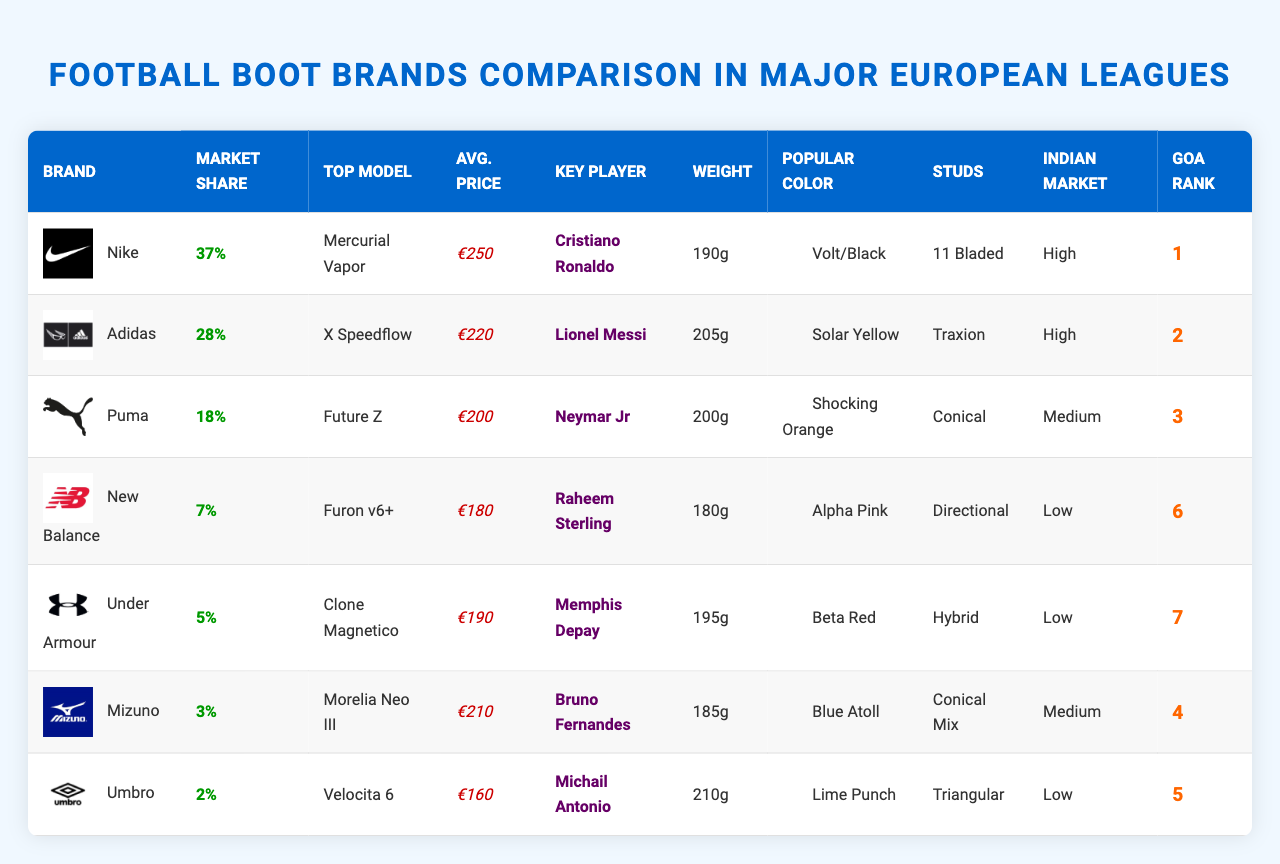What is the market share percentage of Nike boots? According to the table, Nike has a market share of 37%.
Answer: 37% Which boot brand has the highest selling price? The table shows that Nike boots have the highest average price at €250.
Answer: Nike What is the total market share of Adidas and Puma combined? The market share of Adidas is 28% and Puma is 18%. Adding these gives 28% + 18% = 46%.
Answer: 46% Who is the key player ambassador for Mizuno boots? The table lists Bruno Fernandes as the key player ambassador for Mizuno.
Answer: Bruno Fernandes Which brand has the lowest Goa sales rank? Among the brands listed, New Balance has a Goa sales rank of 6, which is the lowest rank on the list.
Answer: New Balance What is the average weight of the listed football boots? To find the average weight, sum all the weights: (190 + 205 + 200 + 180 + 195 + 185 + 210) = 1365 grams. The number of boots is 7, so the average is 1365 / 7 ≈ 195 grams.
Answer: 195 grams Is it true that Umbro has a medium presence in the Indian market? Referring to the table, Umbro has a low presence in the Indian market, so the statement is false.
Answer: No Which boot brand has the most popular color of "Solar Yellow"? The table indicates that "Solar Yellow" is associated with Adidas boots.
Answer: Adidas What is the weight difference between the lightest and heaviest boot brand? The lightest is New Balance at 180g, and the heaviest is Adidas at 205g. The difference is 205g - 180g = 25g.
Answer: 25 grams Among the listed brands, which ones have a high presence in the Indian market? Nike and Adidas both have a high presence as listed in the table.
Answer: Nike and Adidas 